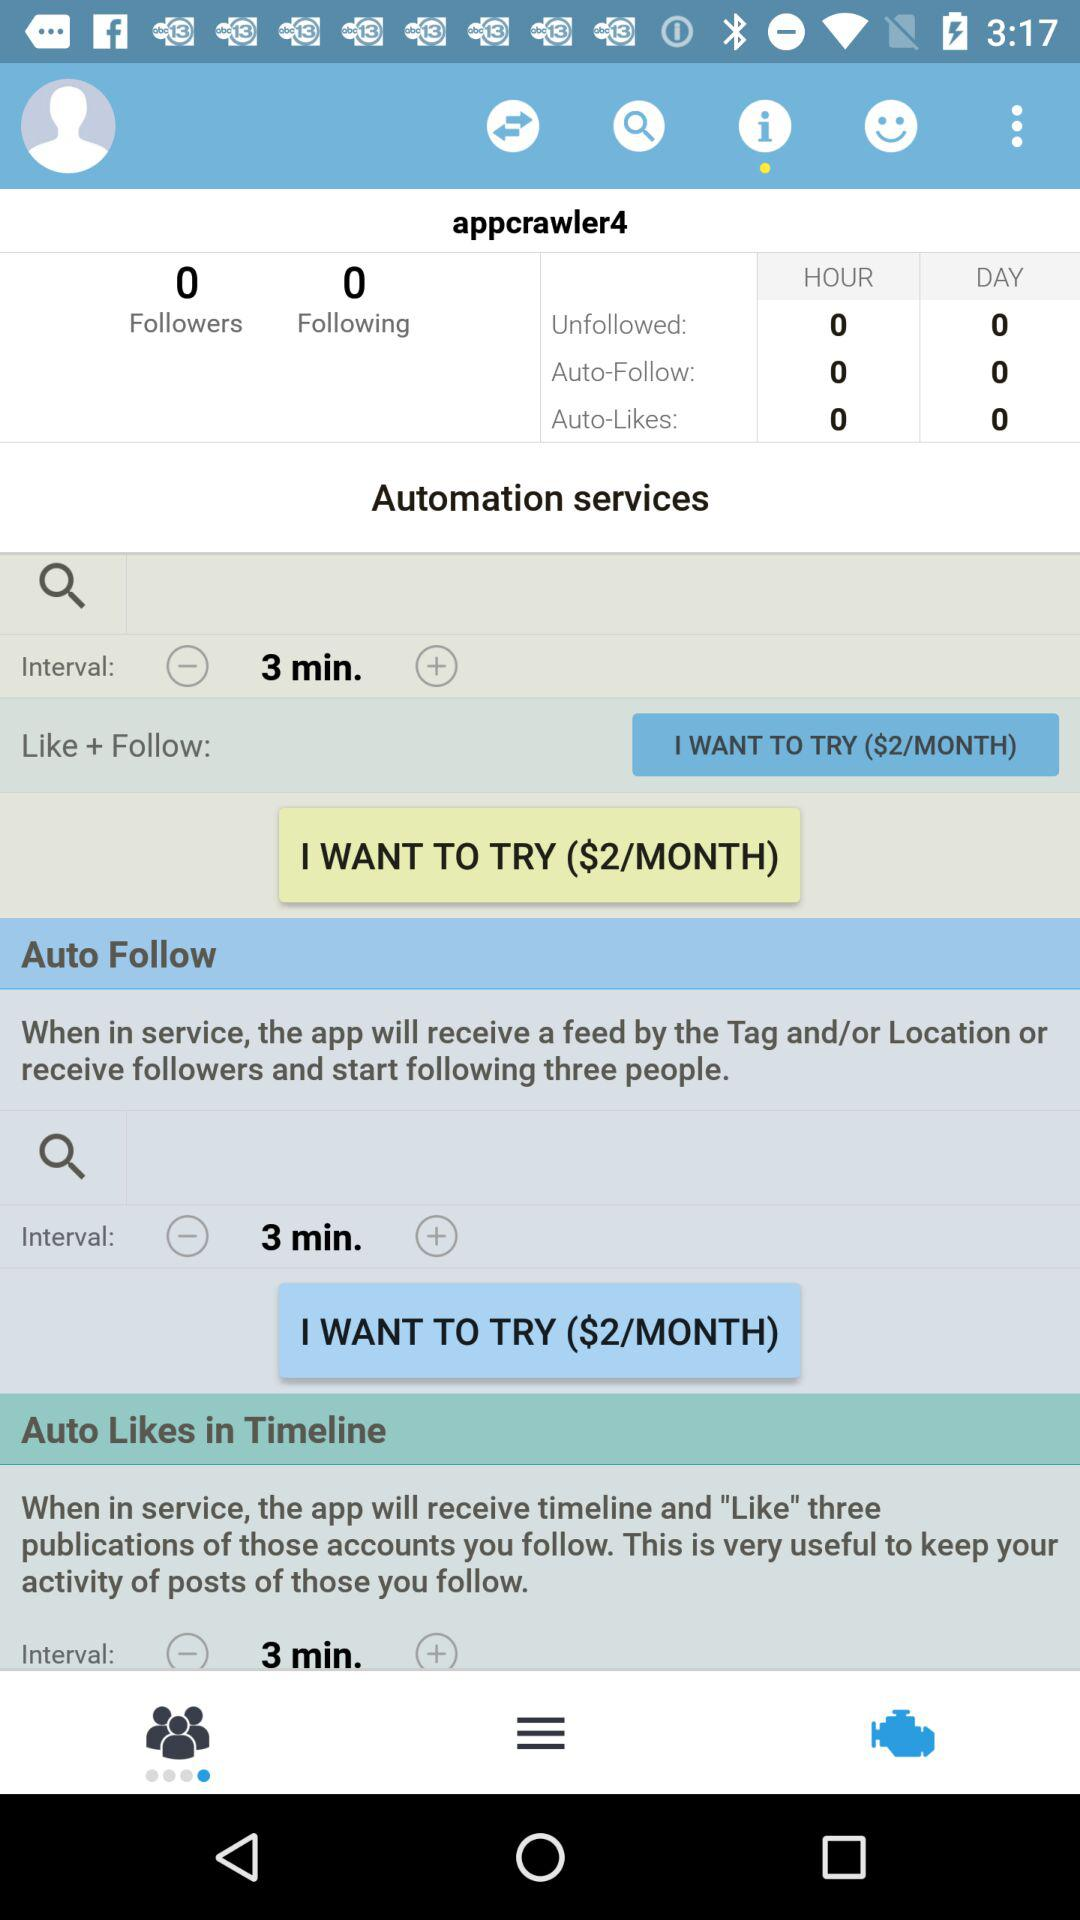What is the user name? The user name is "appcrawler4". 